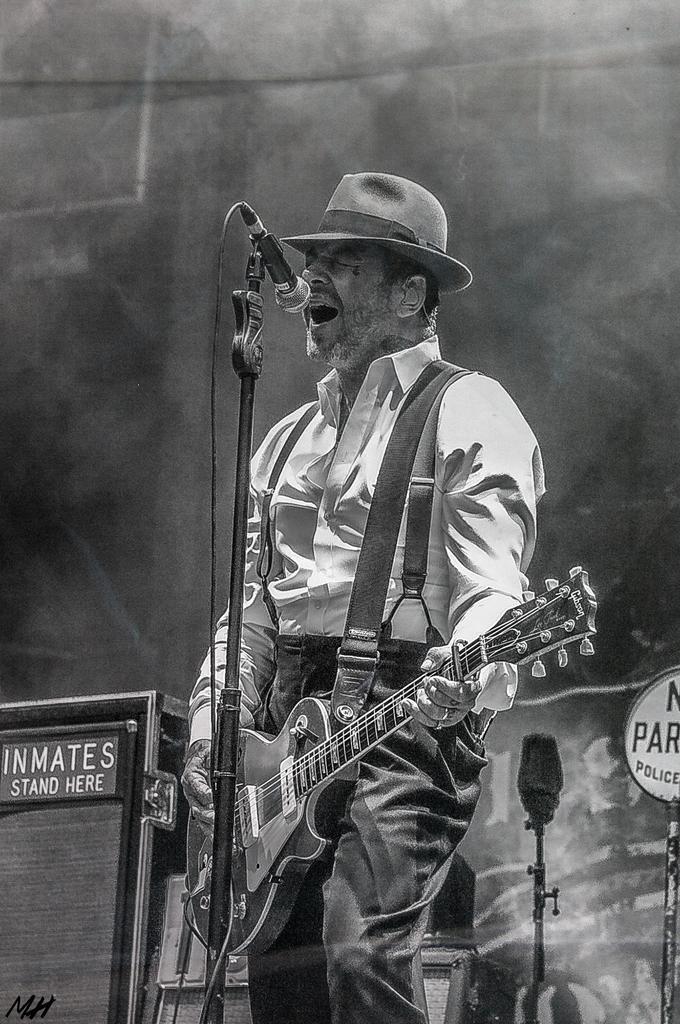Please provide a concise description of this image. In the image we can see there is a man who is standing and he is holding guitar in his hand and the image is in black and white colour. 